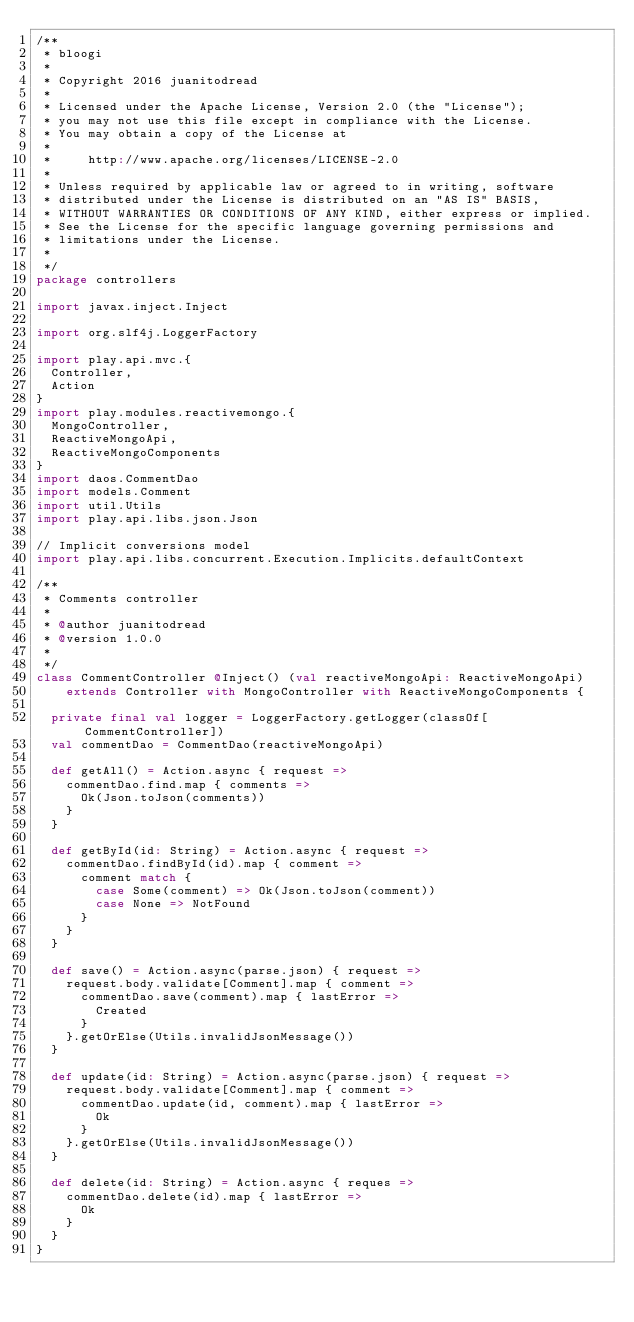<code> <loc_0><loc_0><loc_500><loc_500><_Scala_>/**
 * bloogi
 *
 * Copyright 2016 juanitodread
 *
 * Licensed under the Apache License, Version 2.0 (the "License");
 * you may not use this file except in compliance with the License.
 * You may obtain a copy of the License at
 *
 *     http://www.apache.org/licenses/LICENSE-2.0
 *
 * Unless required by applicable law or agreed to in writing, software
 * distributed under the License is distributed on an "AS IS" BASIS,
 * WITHOUT WARRANTIES OR CONDITIONS OF ANY KIND, either express or implied.
 * See the License for the specific language governing permissions and
 * limitations under the License.
 *
 */
package controllers

import javax.inject.Inject

import org.slf4j.LoggerFactory

import play.api.mvc.{
  Controller,
  Action
}
import play.modules.reactivemongo.{
  MongoController,
  ReactiveMongoApi,
  ReactiveMongoComponents
}
import daos.CommentDao
import models.Comment
import util.Utils
import play.api.libs.json.Json

// Implicit conversions model
import play.api.libs.concurrent.Execution.Implicits.defaultContext

/**
 * Comments controller
 *
 * @author juanitodread
 * @version 1.0.0
 *
 */
class CommentController @Inject() (val reactiveMongoApi: ReactiveMongoApi)
    extends Controller with MongoController with ReactiveMongoComponents {

  private final val logger = LoggerFactory.getLogger(classOf[CommentController])
  val commentDao = CommentDao(reactiveMongoApi)

  def getAll() = Action.async { request =>
    commentDao.find.map { comments =>
      Ok(Json.toJson(comments))
    }
  }

  def getById(id: String) = Action.async { request =>
    commentDao.findById(id).map { comment =>
      comment match {
        case Some(comment) => Ok(Json.toJson(comment))
        case None => NotFound
      }
    }
  }

  def save() = Action.async(parse.json) { request =>
    request.body.validate[Comment].map { comment =>
      commentDao.save(comment).map { lastError =>
        Created
      }
    }.getOrElse(Utils.invalidJsonMessage())
  }

  def update(id: String) = Action.async(parse.json) { request =>
    request.body.validate[Comment].map { comment =>
      commentDao.update(id, comment).map { lastError =>
        Ok
      }
    }.getOrElse(Utils.invalidJsonMessage())
  }

  def delete(id: String) = Action.async { reques =>
    commentDao.delete(id).map { lastError =>
      Ok
    }
  }
}</code> 